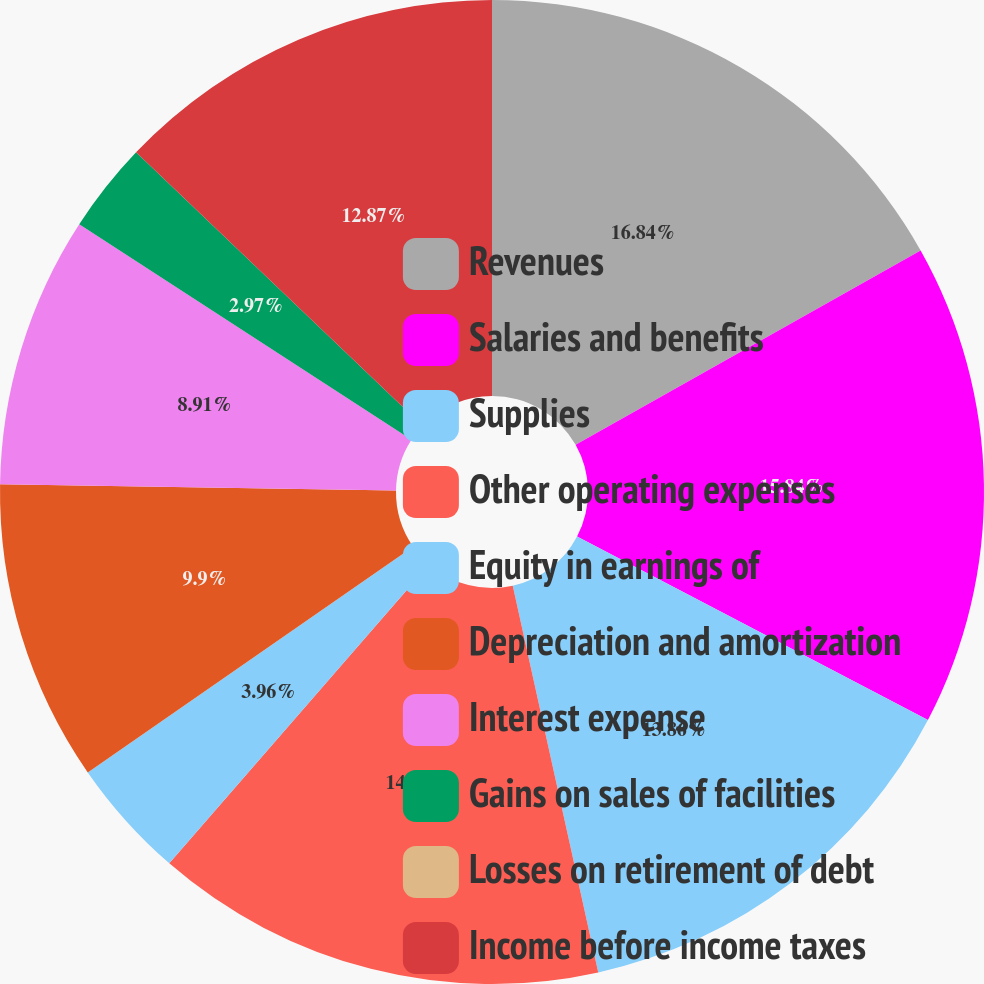Convert chart to OTSL. <chart><loc_0><loc_0><loc_500><loc_500><pie_chart><fcel>Revenues<fcel>Salaries and benefits<fcel>Supplies<fcel>Other operating expenses<fcel>Equity in earnings of<fcel>Depreciation and amortization<fcel>Interest expense<fcel>Gains on sales of facilities<fcel>Losses on retirement of debt<fcel>Income before income taxes<nl><fcel>16.83%<fcel>15.84%<fcel>13.86%<fcel>14.85%<fcel>3.96%<fcel>9.9%<fcel>8.91%<fcel>2.97%<fcel>0.0%<fcel>12.87%<nl></chart> 